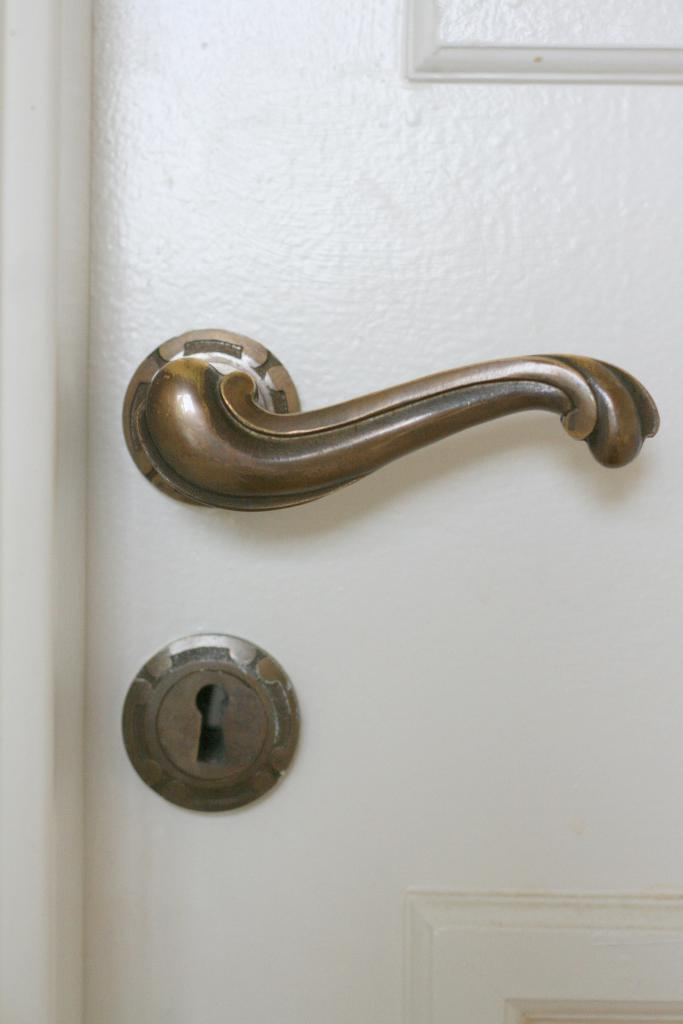What is the main object in the image? There is a door in the image. What feature does the door have for opening and closing? The door has a handle. How can the door be secured? The door has a lock. What type of apparatus is used to water the plants in the image? There is no apparatus or plants present in the image; it only features a door with a handle and a lock. 